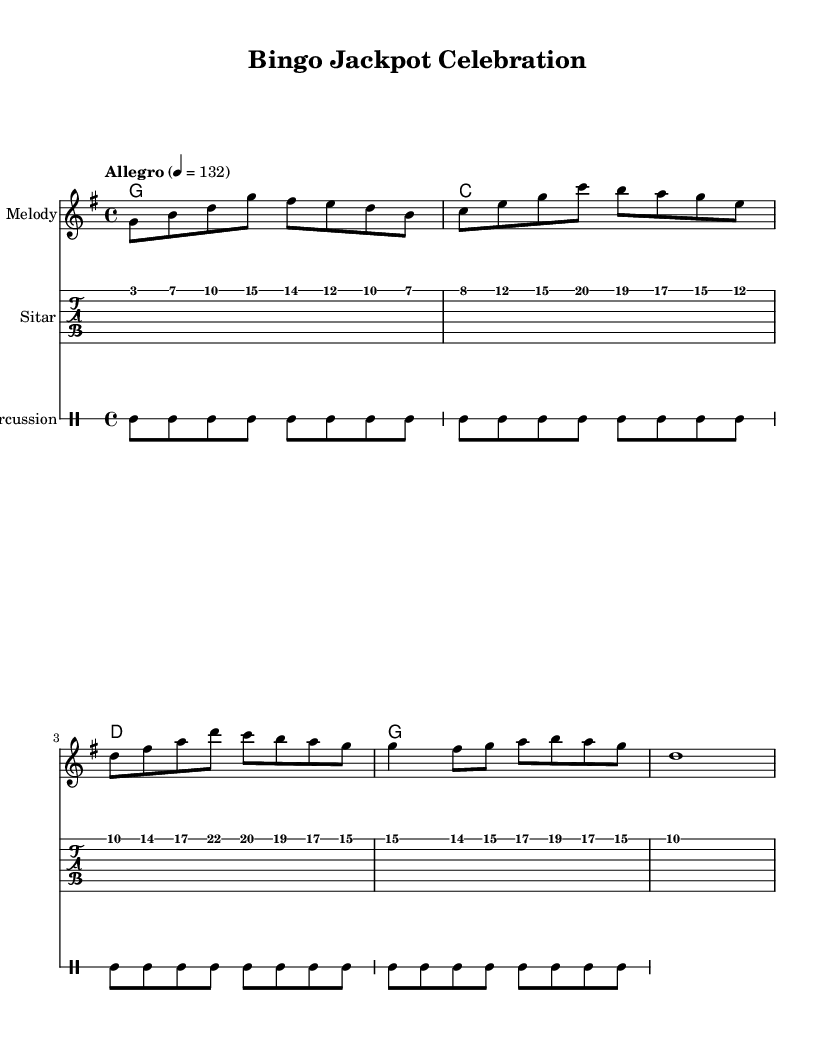What is the key signature of this music? The key signature is G major, which contains one sharp (F#). You can see the sharp symbol next to the F note at the beginning of the staff.
Answer: G major What is the time signature of this music? The time signature is 4/4, indicated by the two numbers at the beginning of the staff. The top number (4) represents the number of beats per measure, while the bottom number (4) indicates the note value that gets one beat (quarter note).
Answer: 4/4 What is the tempo marking for this piece? The tempo marking is "Allegro," with a metronome marking of 132 beats per minute. This information is provided in the tempo text at the beginning of the score.
Answer: Allegro How many measures are there in the melody section? There are 8 measures in the melody section, as indicated by the grouping of notes and the vertical bar lines that separate each measure.
Answer: 8 What type of percussion is featured in this score? The percussion part is indicated as "DrumStaff," with a bass drum and snare drum pattern. The notation specifies a repeating bass drum and snare drum pattern which is standard in festive Bollywood music.
Answer: Percussion What is the highest note in the melody? The highest note in the melody is D, which can be found in the first three notes of the melody section where it is the second note.
Answer: D What musical style is represented in this score? The musical style represented in this score is festive Bollywood dance tracks, as indicated by the lively tempo, the use of traditional Indian instrumentation like the sitar, and the celebratory overall feel of the composition.
Answer: Festive Bollywood 